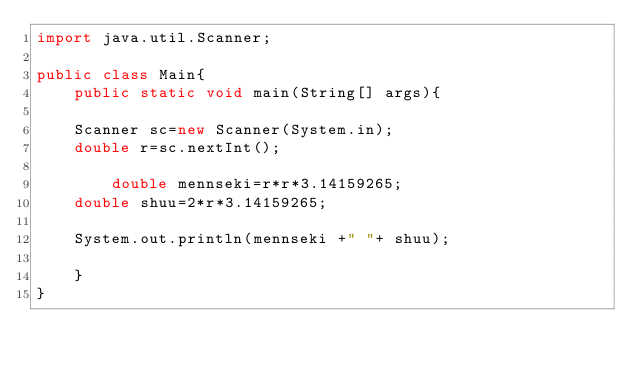Convert code to text. <code><loc_0><loc_0><loc_500><loc_500><_Java_>import java.util.Scanner;

public class Main{
    public static void main(String[] args){

	Scanner sc=new Scanner(System.in);
	double r=sc.nextInt();

        double mennseki=r*r*3.14159265;
	double shuu=2*r*3.14159265;
	
	System.out.println(mennseki +" "+ shuu);

    }
}</code> 